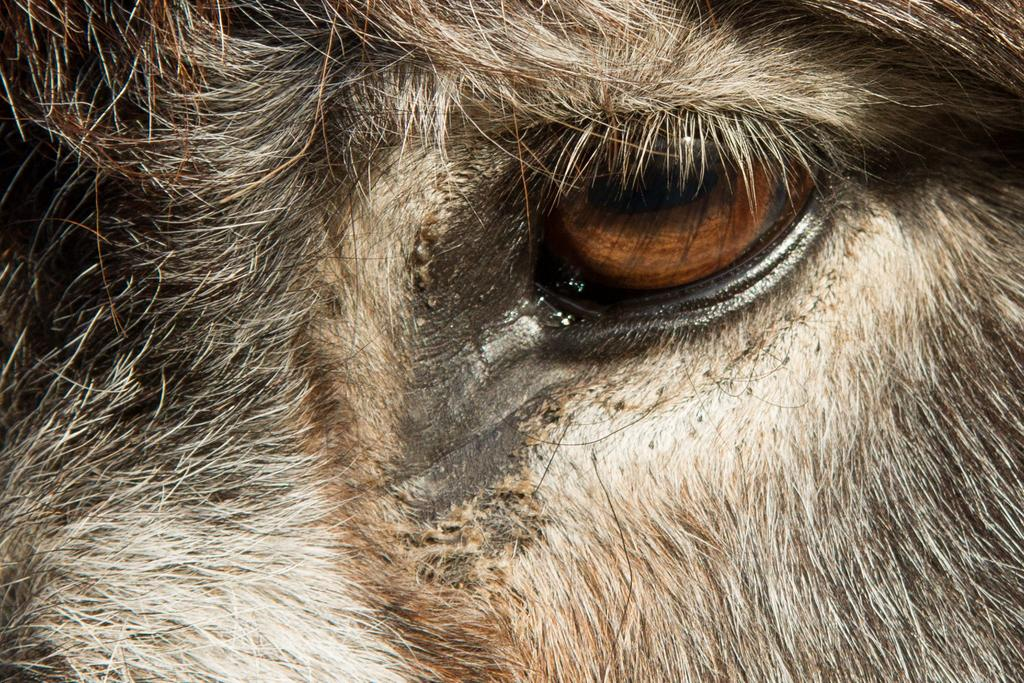What is the main subject of the image? The main subject of the image is an animal's eye. How many cracks can be seen in the animal's eye in the image? There are no cracks visible in the animal's eye in the image. The image does not show any cracks in the animal's eye. The question is absurd because it assumes the presence of cracks, which is not supported by the provided fact. 